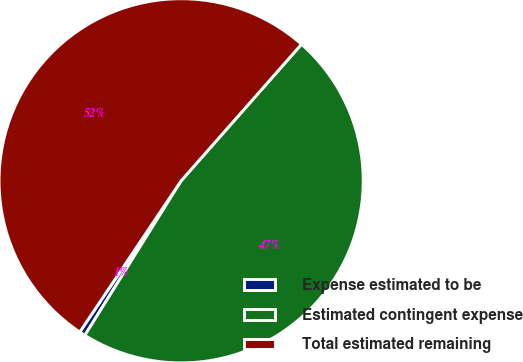Convert chart to OTSL. <chart><loc_0><loc_0><loc_500><loc_500><pie_chart><fcel>Expense estimated to be<fcel>Estimated contingent expense<fcel>Total estimated remaining<nl><fcel>0.53%<fcel>47.37%<fcel>52.1%<nl></chart> 